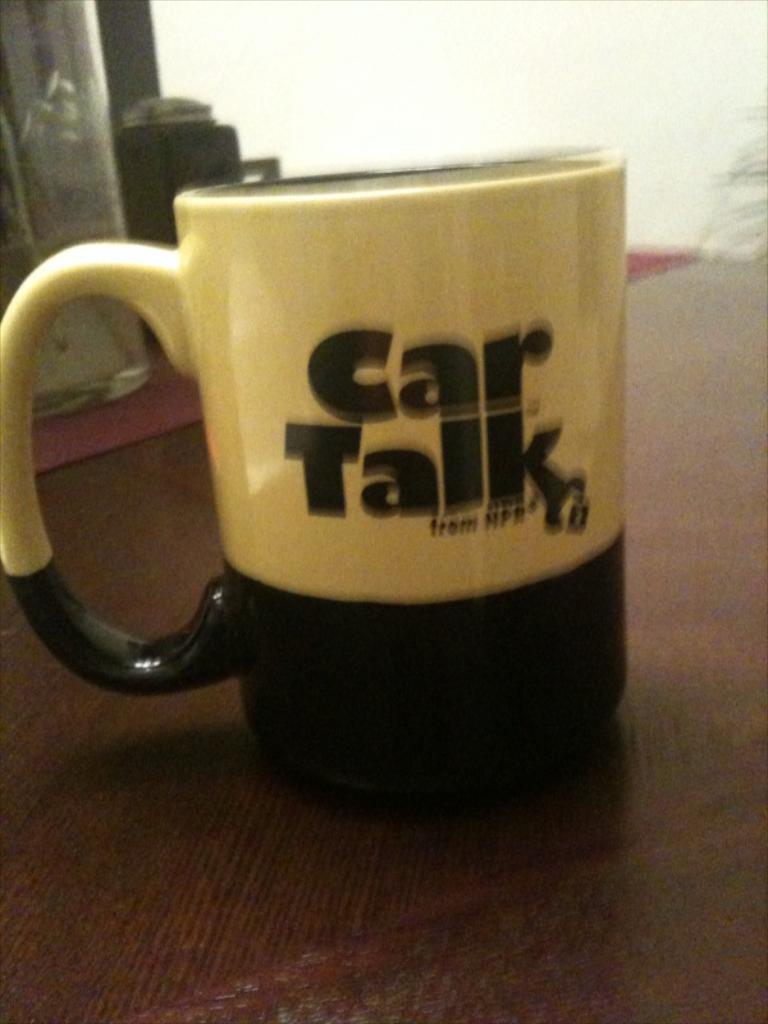What kind of talk is on this cup?
Your answer should be very brief. Car. What radio show is written on the mug?
Keep it short and to the point. Car talk. 